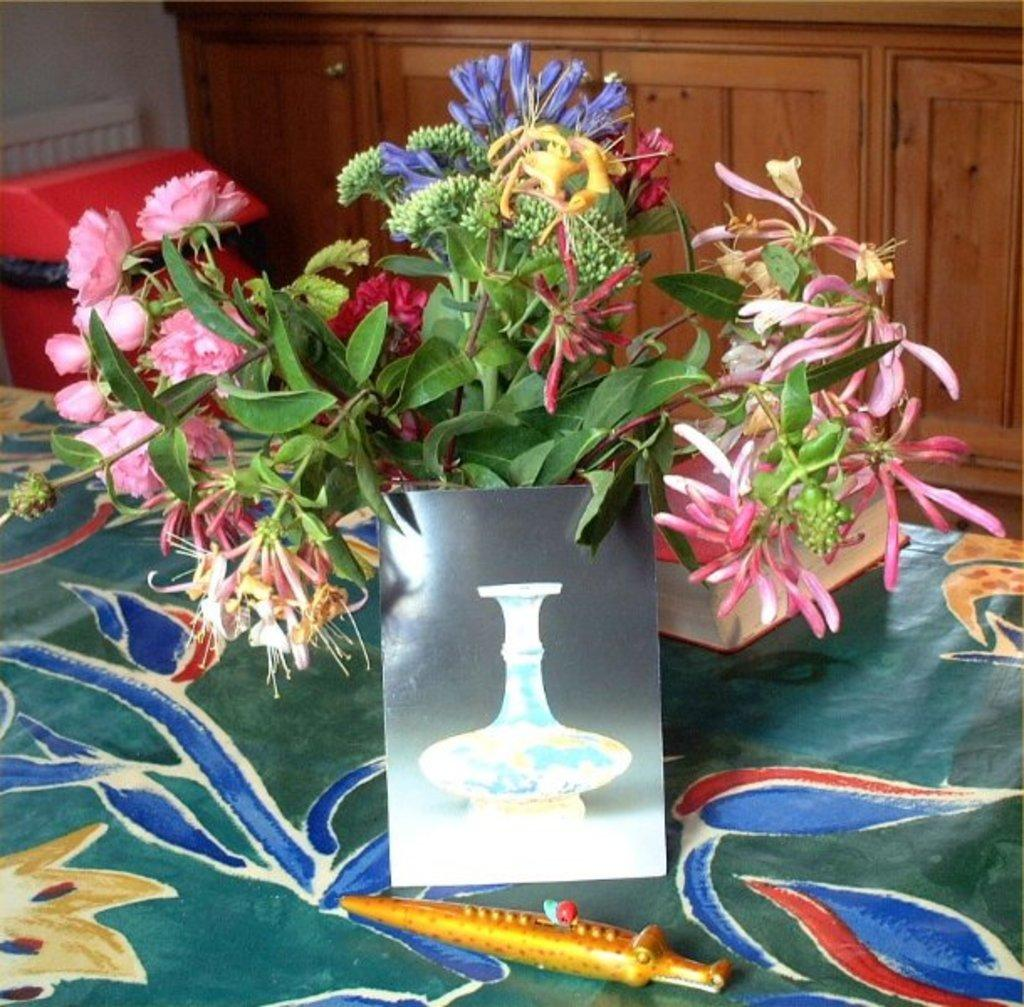What object is located in the foreground of the image? There is a knife in the foreground of the image. What is placed next to the knife in the foreground? There is a board in the foreground of the image. What type of plants can be seen in the foreground of the image? There are houseplants on a table in the foreground of the image. Can you describe the setting of the image? The image appears to be taken in a room. What can be seen in the background of the image? There are shelves and a wall in the background of the image. How many flies can be seen on the wall in the image? There are no flies visible in the image. What type of tool is the crook used for in the image? There is no crook present in the image. 